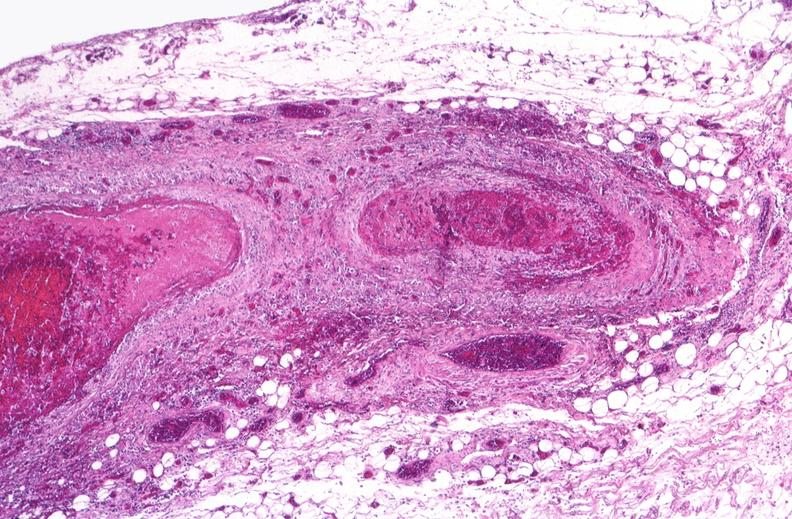where is this from?
Answer the question using a single word or phrase. Vasculature 